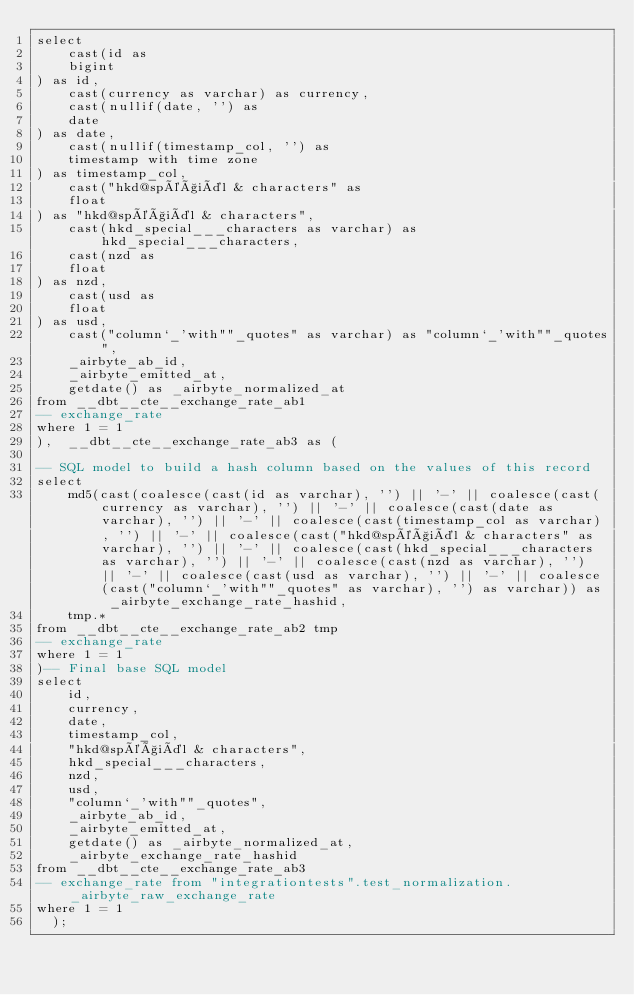<code> <loc_0><loc_0><loc_500><loc_500><_SQL_>select
    cast(id as 
    bigint
) as id,
    cast(currency as varchar) as currency,
    cast(nullif(date, '') as 
    date
) as date,
    cast(nullif(timestamp_col, '') as 
    timestamp with time zone
) as timestamp_col,
    cast("hkd@spéçiäl & characters" as 
    float
) as "hkd@spéçiäl & characters",
    cast(hkd_special___characters as varchar) as hkd_special___characters,
    cast(nzd as 
    float
) as nzd,
    cast(usd as 
    float
) as usd,
    cast("column`_'with""_quotes" as varchar) as "column`_'with""_quotes",
    _airbyte_ab_id,
    _airbyte_emitted_at,
    getdate() as _airbyte_normalized_at
from __dbt__cte__exchange_rate_ab1
-- exchange_rate
where 1 = 1
),  __dbt__cte__exchange_rate_ab3 as (

-- SQL model to build a hash column based on the values of this record
select
    md5(cast(coalesce(cast(id as varchar), '') || '-' || coalesce(cast(currency as varchar), '') || '-' || coalesce(cast(date as varchar), '') || '-' || coalesce(cast(timestamp_col as varchar), '') || '-' || coalesce(cast("hkd@spéçiäl & characters" as varchar), '') || '-' || coalesce(cast(hkd_special___characters as varchar), '') || '-' || coalesce(cast(nzd as varchar), '') || '-' || coalesce(cast(usd as varchar), '') || '-' || coalesce(cast("column`_'with""_quotes" as varchar), '') as varchar)) as _airbyte_exchange_rate_hashid,
    tmp.*
from __dbt__cte__exchange_rate_ab2 tmp
-- exchange_rate
where 1 = 1
)-- Final base SQL model
select
    id,
    currency,
    date,
    timestamp_col,
    "hkd@spéçiäl & characters",
    hkd_special___characters,
    nzd,
    usd,
    "column`_'with""_quotes",
    _airbyte_ab_id,
    _airbyte_emitted_at,
    getdate() as _airbyte_normalized_at,
    _airbyte_exchange_rate_hashid
from __dbt__cte__exchange_rate_ab3
-- exchange_rate from "integrationtests".test_normalization._airbyte_raw_exchange_rate
where 1 = 1
  );</code> 